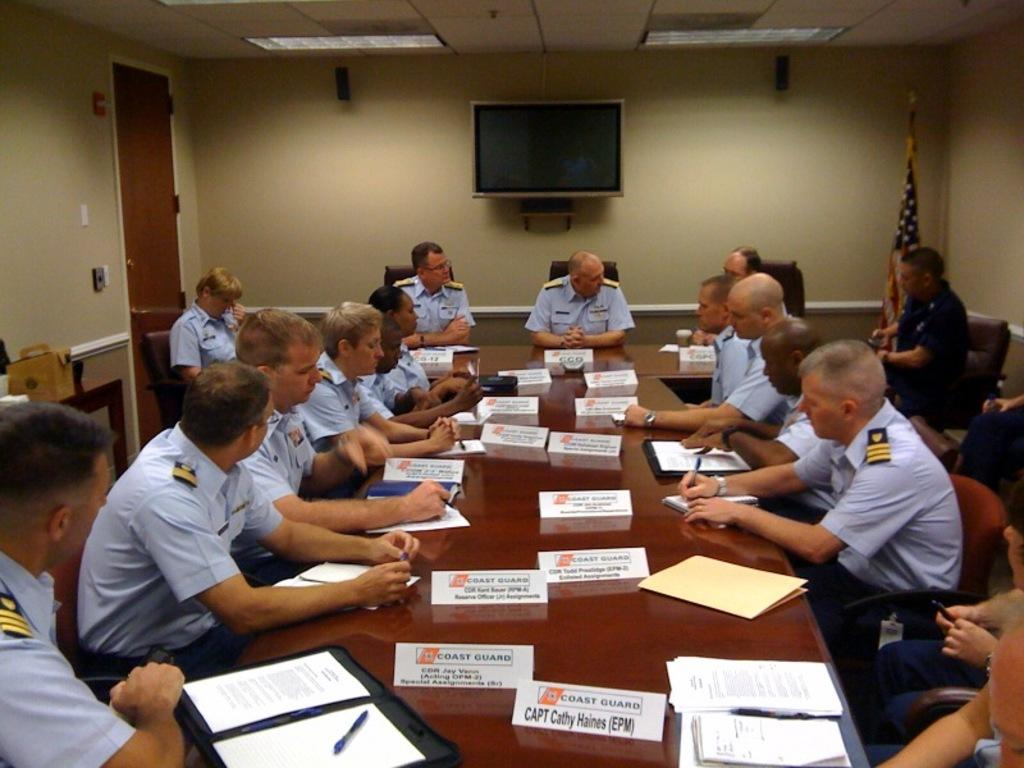<image>
Provide a brief description of the given image. Members of the Coast Gaurd are sitting at a long table in what looks to be a meeting. 